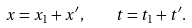Convert formula to latex. <formula><loc_0><loc_0><loc_500><loc_500>x = x _ { 1 } + x ^ { \prime } , \quad t = t _ { 1 } + t ^ { \prime } .</formula> 